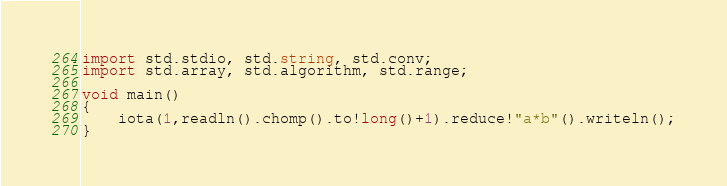Convert code to text. <code><loc_0><loc_0><loc_500><loc_500><_D_>import std.stdio, std.string, std.conv;
import std.array, std.algorithm, std.range;

void main()
{
    iota(1,readln().chomp().to!long()+1).reduce!"a*b"().writeln();
}</code> 